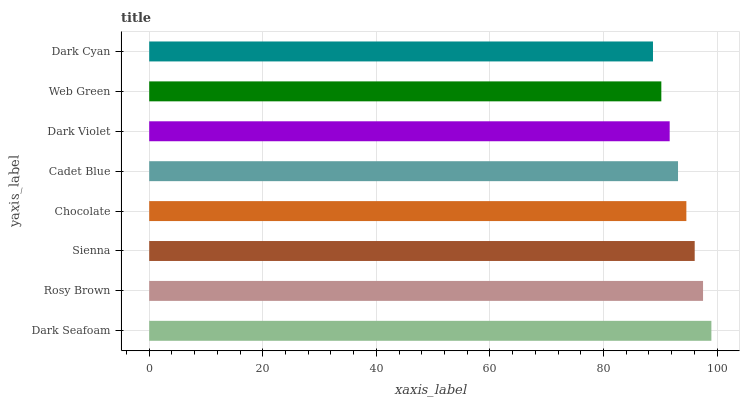Is Dark Cyan the minimum?
Answer yes or no. Yes. Is Dark Seafoam the maximum?
Answer yes or no. Yes. Is Rosy Brown the minimum?
Answer yes or no. No. Is Rosy Brown the maximum?
Answer yes or no. No. Is Dark Seafoam greater than Rosy Brown?
Answer yes or no. Yes. Is Rosy Brown less than Dark Seafoam?
Answer yes or no. Yes. Is Rosy Brown greater than Dark Seafoam?
Answer yes or no. No. Is Dark Seafoam less than Rosy Brown?
Answer yes or no. No. Is Chocolate the high median?
Answer yes or no. Yes. Is Cadet Blue the low median?
Answer yes or no. Yes. Is Web Green the high median?
Answer yes or no. No. Is Dark Violet the low median?
Answer yes or no. No. 